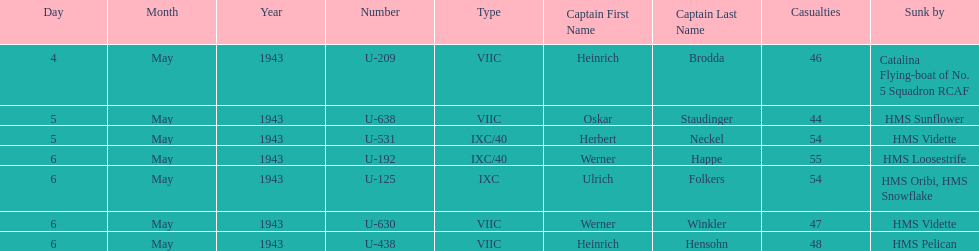What was the only captain sunk by hms pelican? Heinrich Hensohn. 